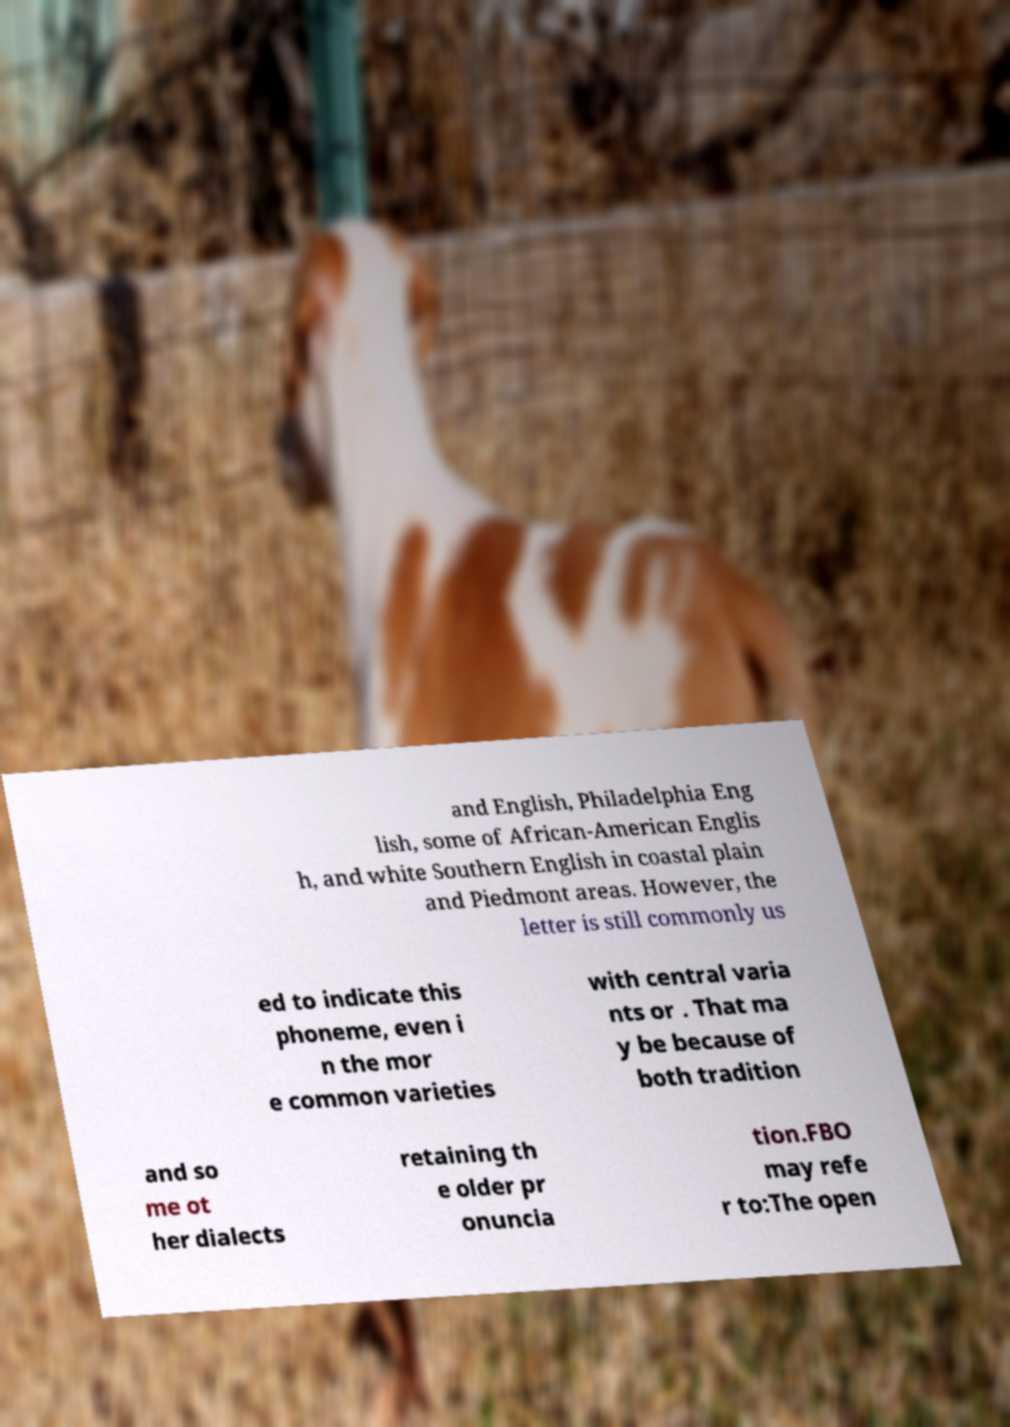Could you assist in decoding the text presented in this image and type it out clearly? and English, Philadelphia Eng lish, some of African-American Englis h, and white Southern English in coastal plain and Piedmont areas. However, the letter is still commonly us ed to indicate this phoneme, even i n the mor e common varieties with central varia nts or . That ma y be because of both tradition and so me ot her dialects retaining th e older pr onuncia tion.FBO may refe r to:The open 